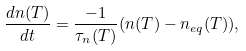<formula> <loc_0><loc_0><loc_500><loc_500>\frac { d n ( T ) } { d t } = \frac { - 1 } { \tau _ { n } ( T ) } ( n ( T ) - n _ { e q } ( T ) ) ,</formula> 